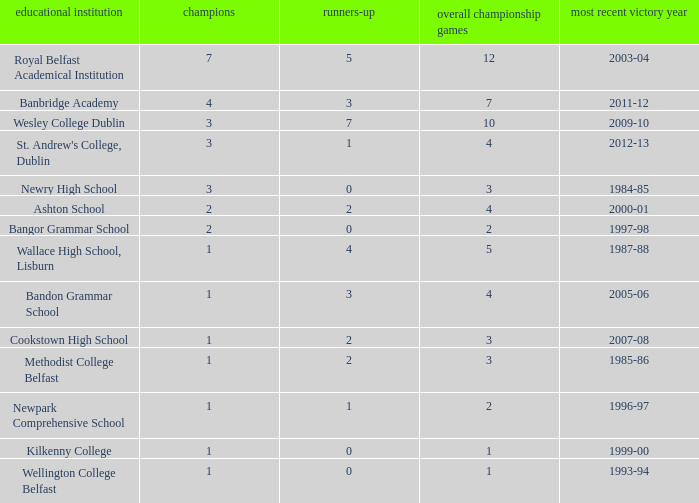In what year was the total finals at 10? 2009-10. 